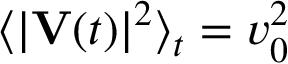Convert formula to latex. <formula><loc_0><loc_0><loc_500><loc_500>\langle | V ( t ) | ^ { 2 } \rangle _ { t } = v _ { 0 } ^ { 2 }</formula> 